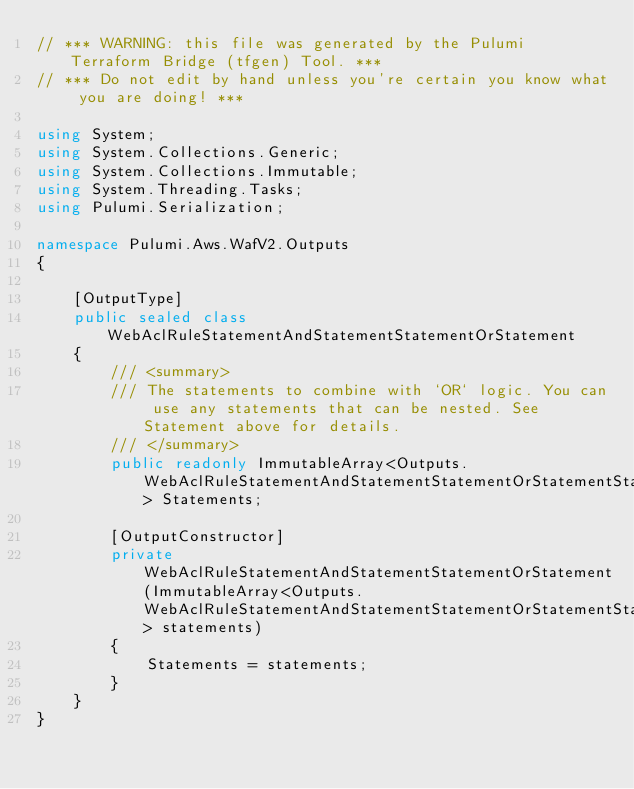<code> <loc_0><loc_0><loc_500><loc_500><_C#_>// *** WARNING: this file was generated by the Pulumi Terraform Bridge (tfgen) Tool. ***
// *** Do not edit by hand unless you're certain you know what you are doing! ***

using System;
using System.Collections.Generic;
using System.Collections.Immutable;
using System.Threading.Tasks;
using Pulumi.Serialization;

namespace Pulumi.Aws.WafV2.Outputs
{

    [OutputType]
    public sealed class WebAclRuleStatementAndStatementStatementOrStatement
    {
        /// <summary>
        /// The statements to combine with `OR` logic. You can use any statements that can be nested. See Statement above for details.
        /// </summary>
        public readonly ImmutableArray<Outputs.WebAclRuleStatementAndStatementStatementOrStatementStatement> Statements;

        [OutputConstructor]
        private WebAclRuleStatementAndStatementStatementOrStatement(ImmutableArray<Outputs.WebAclRuleStatementAndStatementStatementOrStatementStatement> statements)
        {
            Statements = statements;
        }
    }
}
</code> 